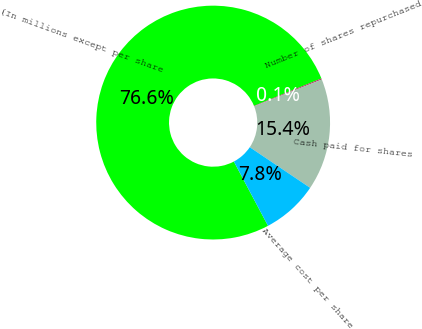Convert chart. <chart><loc_0><loc_0><loc_500><loc_500><pie_chart><fcel>(In millions except per share<fcel>Number of shares repurchased<fcel>Cash paid for shares<fcel>Average cost per share<nl><fcel>76.61%<fcel>0.15%<fcel>15.44%<fcel>7.8%<nl></chart> 